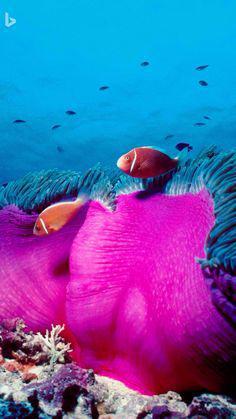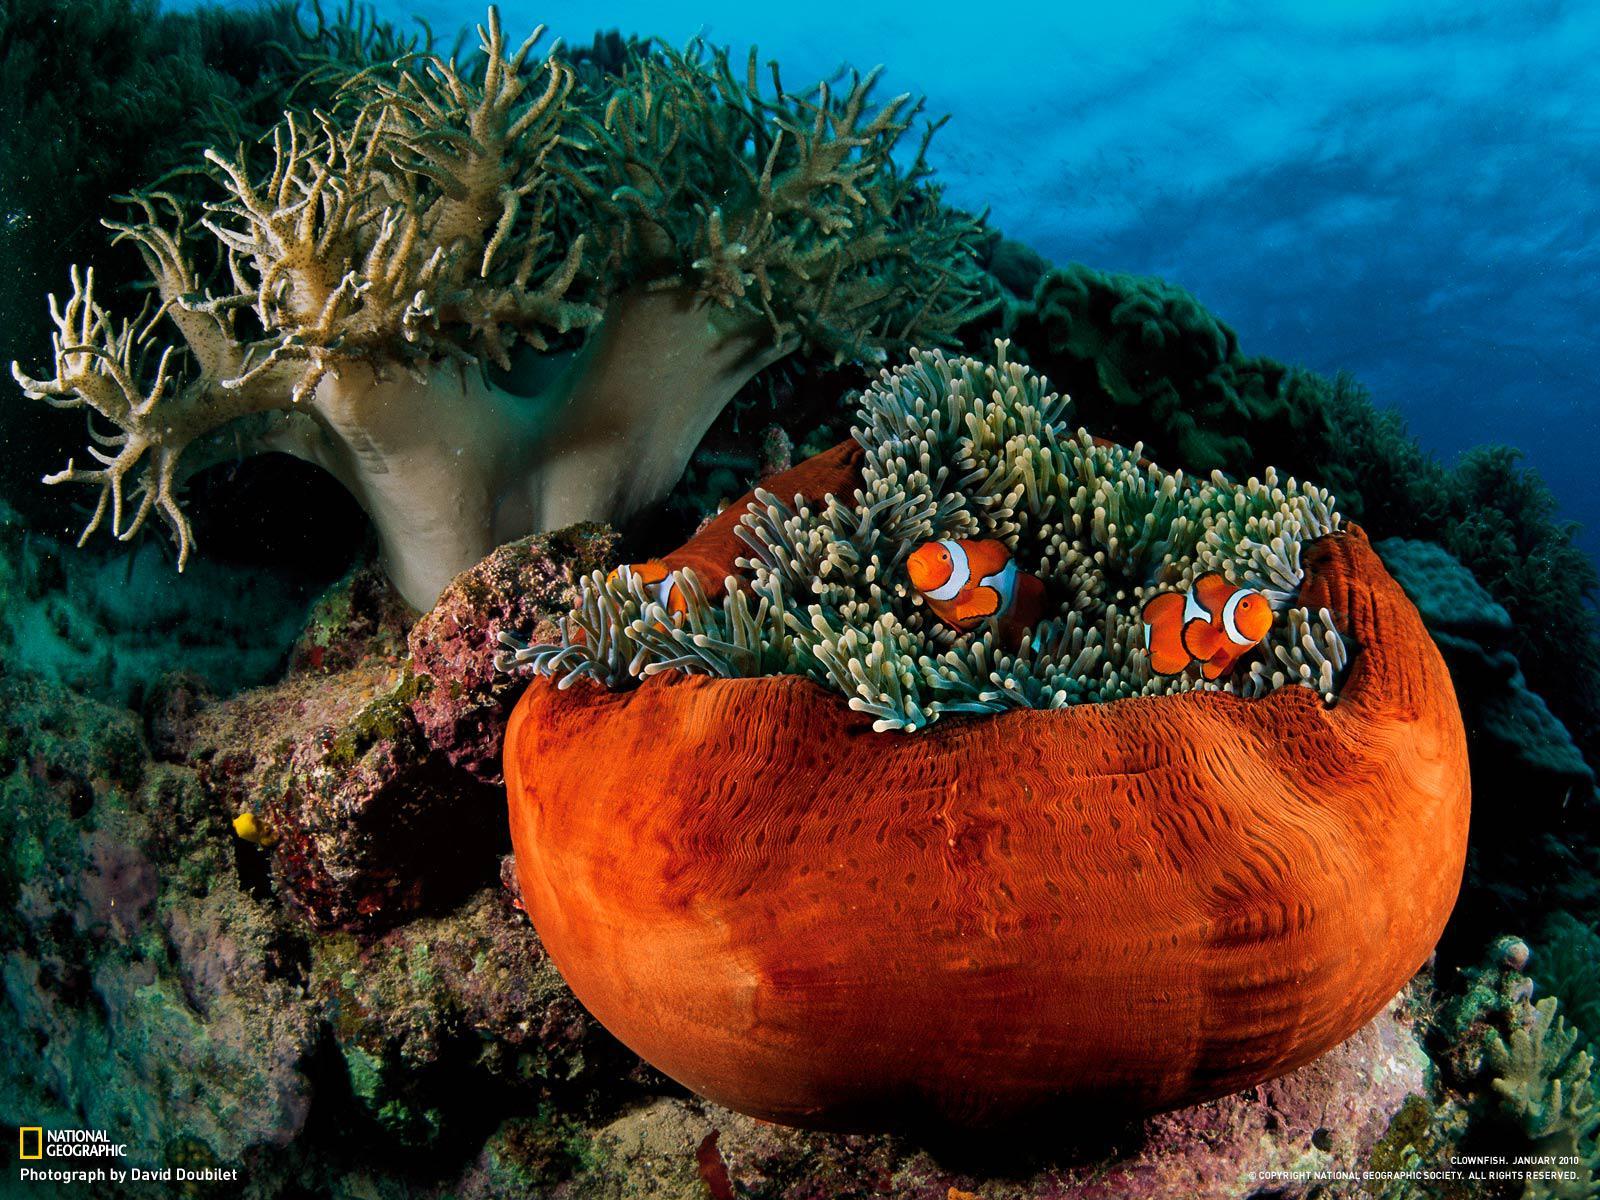The first image is the image on the left, the second image is the image on the right. For the images displayed, is the sentence "In at least one image there is a hot pink collar with an orange and pink fish swimming on top of it." factually correct? Answer yes or no. Yes. The first image is the image on the left, the second image is the image on the right. For the images displayed, is the sentence "The left image contains a single fish." factually correct? Answer yes or no. No. 